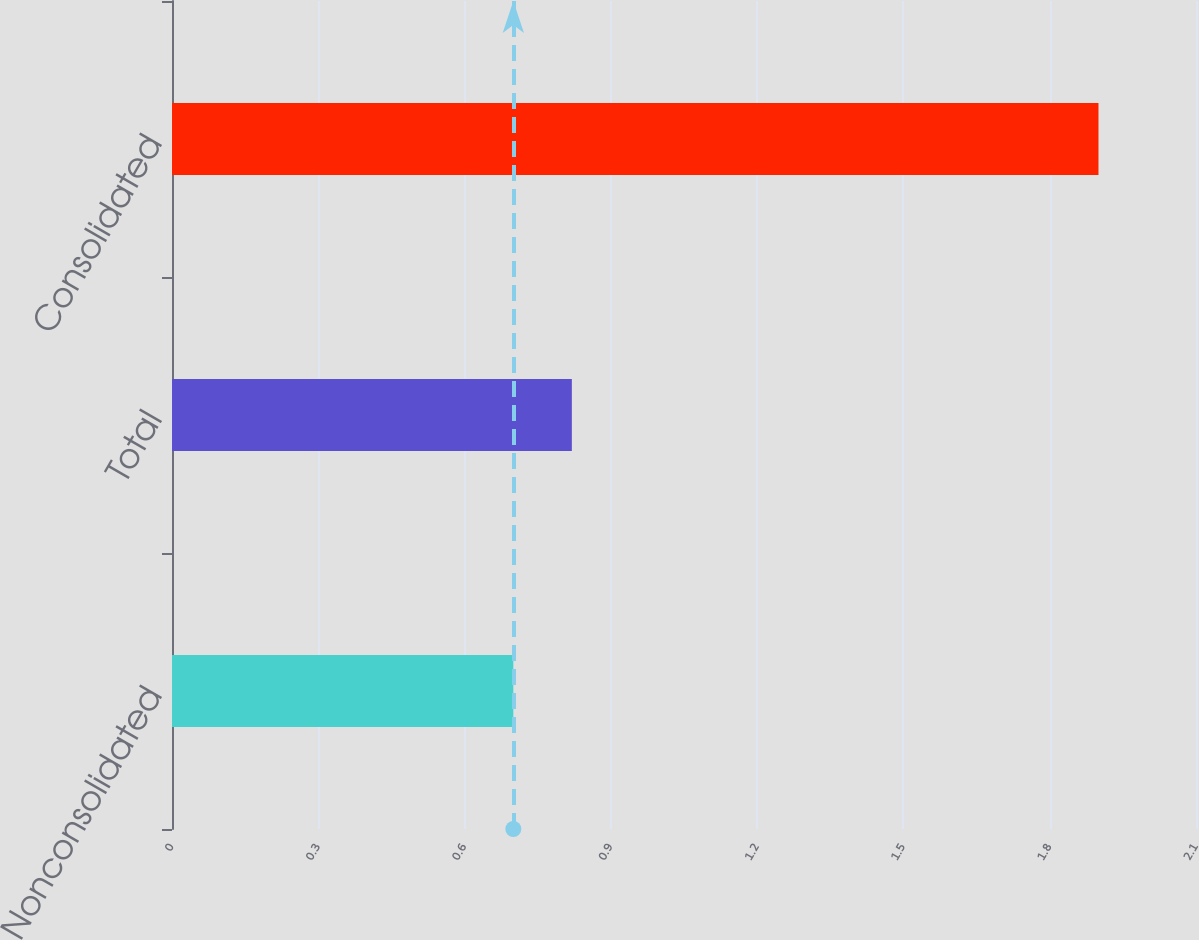<chart> <loc_0><loc_0><loc_500><loc_500><bar_chart><fcel>Nonconsolidated<fcel>Total<fcel>Consolidated<nl><fcel>0.7<fcel>0.82<fcel>1.9<nl></chart> 